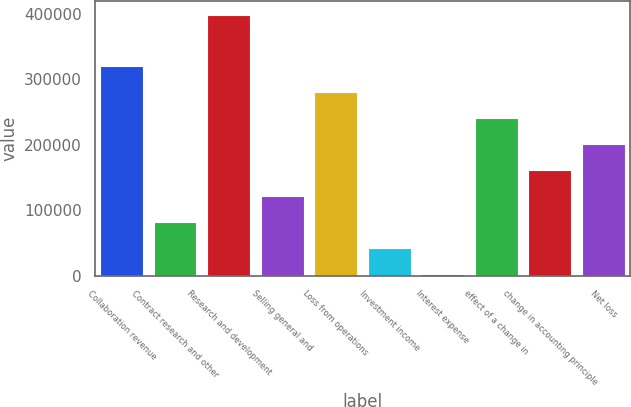<chart> <loc_0><loc_0><loc_500><loc_500><bar_chart><fcel>Collaboration revenue<fcel>Contract research and other<fcel>Research and development<fcel>Selling general and<fcel>Loss from operations<fcel>Investment income<fcel>Interest expense<fcel>effect of a change in<fcel>change in accounting principle<fcel>Net loss<nl><fcel>319477<fcel>81622<fcel>398762<fcel>121264<fcel>279834<fcel>41979.5<fcel>2337<fcel>240192<fcel>160907<fcel>200550<nl></chart> 